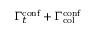Convert formula to latex. <formula><loc_0><loc_0><loc_500><loc_500>\Gamma _ { t } ^ { c o n f } + \Gamma _ { c o l } ^ { c o n f }</formula> 